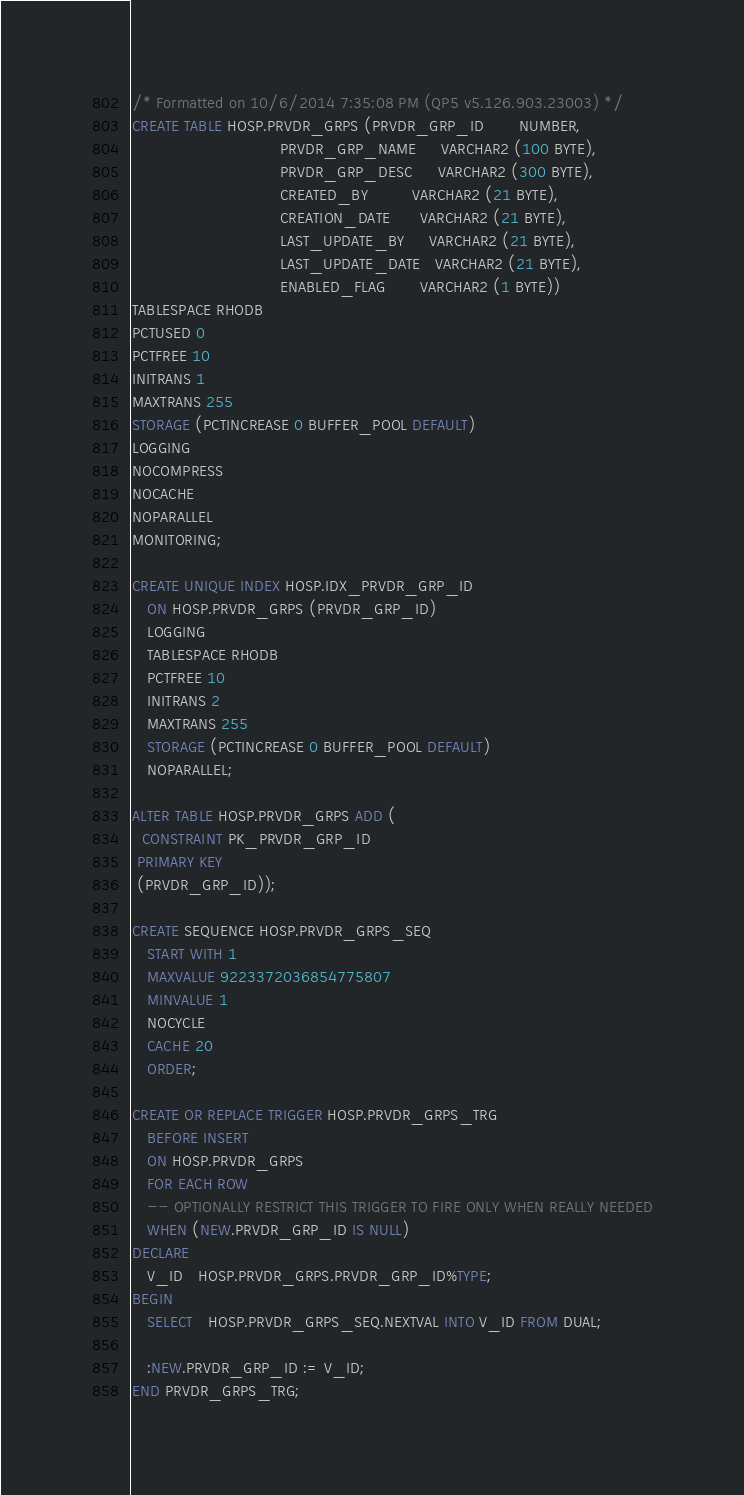Convert code to text. <code><loc_0><loc_0><loc_500><loc_500><_SQL_>/* Formatted on 10/6/2014 7:35:08 PM (QP5 v5.126.903.23003) */
CREATE TABLE HOSP.PRVDR_GRPS (PRVDR_GRP_ID       NUMBER,
                              PRVDR_GRP_NAME     VARCHAR2 (100 BYTE),
                              PRVDR_GRP_DESC     VARCHAR2 (300 BYTE),
                              CREATED_BY         VARCHAR2 (21 BYTE),
                              CREATION_DATE      VARCHAR2 (21 BYTE),
                              LAST_UPDATE_BY     VARCHAR2 (21 BYTE),
                              LAST_UPDATE_DATE   VARCHAR2 (21 BYTE),
                              ENABLED_FLAG       VARCHAR2 (1 BYTE))
TABLESPACE RHODB
PCTUSED 0
PCTFREE 10
INITRANS 1
MAXTRANS 255
STORAGE (PCTINCREASE 0 BUFFER_POOL DEFAULT)
LOGGING
NOCOMPRESS
NOCACHE
NOPARALLEL
MONITORING;

CREATE UNIQUE INDEX HOSP.IDX_PRVDR_GRP_ID
   ON HOSP.PRVDR_GRPS (PRVDR_GRP_ID)
   LOGGING
   TABLESPACE RHODB
   PCTFREE 10
   INITRANS 2
   MAXTRANS 255
   STORAGE (PCTINCREASE 0 BUFFER_POOL DEFAULT)
   NOPARALLEL;

ALTER TABLE HOSP.PRVDR_GRPS ADD (
  CONSTRAINT PK_PRVDR_GRP_ID
 PRIMARY KEY
 (PRVDR_GRP_ID));

CREATE SEQUENCE HOSP.PRVDR_GRPS_SEQ
   START WITH 1
   MAXVALUE 9223372036854775807
   MINVALUE 1
   NOCYCLE
   CACHE 20
   ORDER;

CREATE OR REPLACE TRIGGER HOSP.PRVDR_GRPS_TRG
   BEFORE INSERT
   ON HOSP.PRVDR_GRPS
   FOR EACH ROW
   -- OPTIONALLY RESTRICT THIS TRIGGER TO FIRE ONLY WHEN REALLY NEEDED
   WHEN (NEW.PRVDR_GRP_ID IS NULL)
DECLARE
   V_ID   HOSP.PRVDR_GRPS.PRVDR_GRP_ID%TYPE;
BEGIN
   SELECT   HOSP.PRVDR_GRPS_SEQ.NEXTVAL INTO V_ID FROM DUAL;

   :NEW.PRVDR_GRP_ID := V_ID;
END PRVDR_GRPS_TRG;</code> 